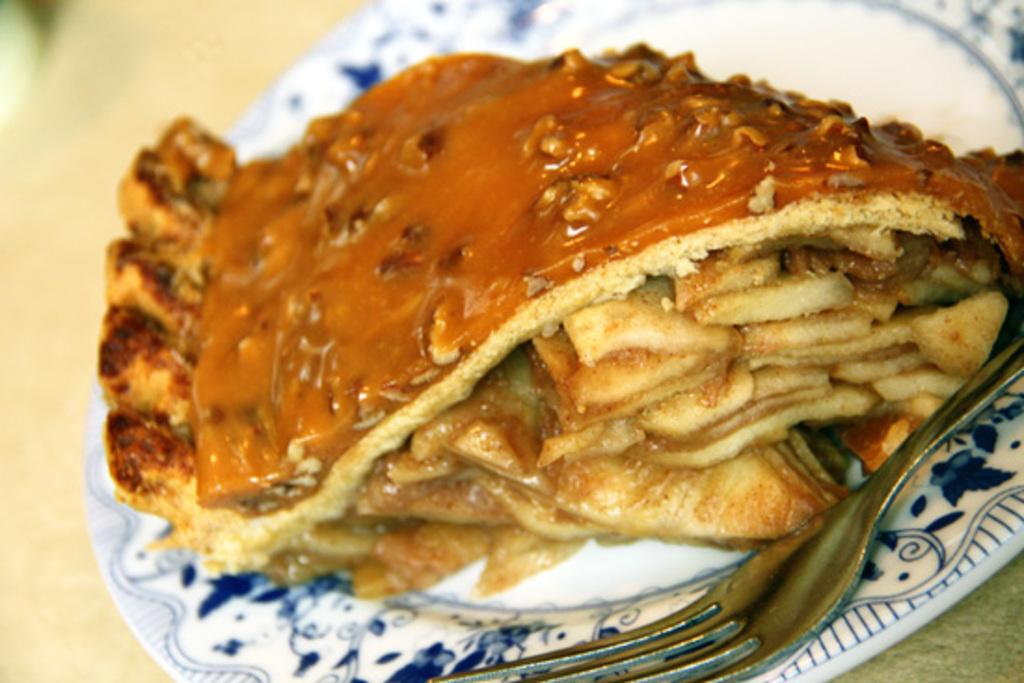What type of food can be seen in the image? The food in the image is in brown color. What color is the plate that the food is on? The plate is in white color. Where is the fork located in the image? The fork is on the right side of the image. What statement does the stick make in the image? There is no stick present in the image, so it cannot make any statements. 